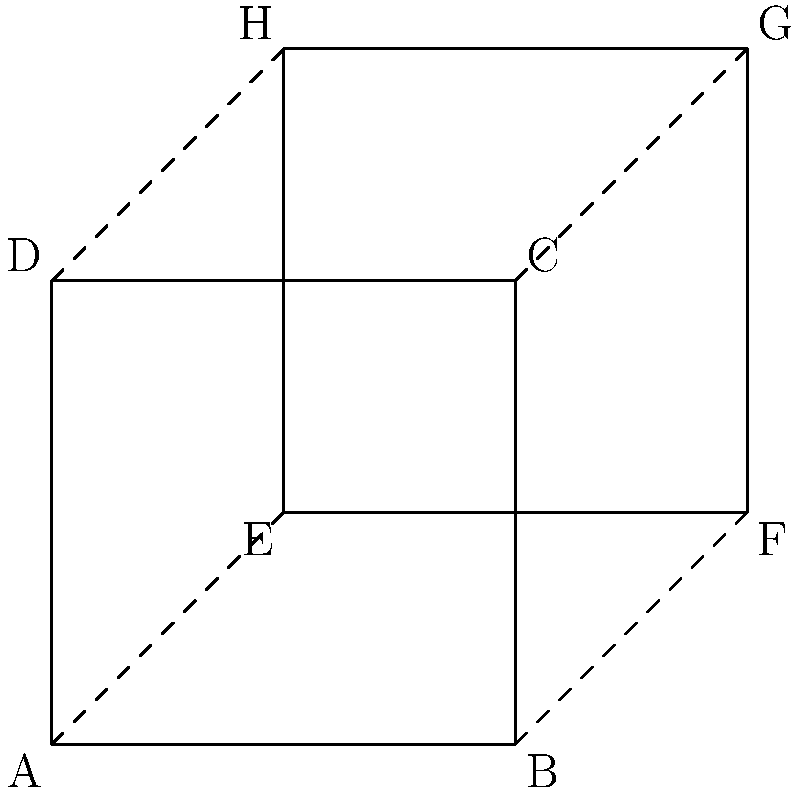In the figure above, square ABCD has been transformed to create square EFGH. If this transformation is applied three more times in succession, what will be the coordinates of point G after the final transformation? Let's approach this step-by-step:

1) First, we need to identify the transformation:
   - The square has been rotated 45° clockwise around its center.
   - It has also been translated 1 unit to the right and 1 unit up.

2) Let's track point G through each transformation:
   - Initially, G is at (3,3)

3) After the first transformation (the one shown):
   - G moves to (3,3)

4) After the second transformation:
   - Rotation: (3,3) → (5,1)
   - Translation: (5,1) → (6,2)

5) After the third transformation:
   - Rotation: (6,2) → (7,-1)
   - Translation: (7,-1) → (8,0)

6) After the fourth and final transformation:
   - Rotation: (8,0) → (7,-3)
   - Translation: (7,-3) → (8,-2)

Therefore, after four successive applications of the transformation, point G will be at coordinates (8,-2).
Answer: (8,-2) 